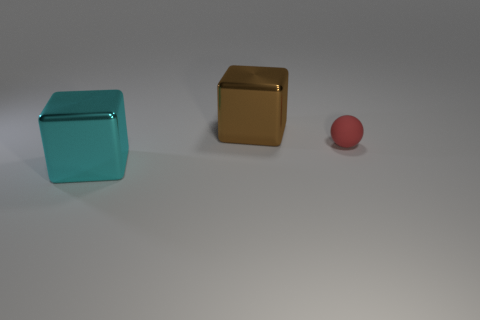Is there any other thing that has the same material as the sphere?
Your answer should be compact. No. Are there any other things that are the same size as the red rubber thing?
Offer a very short reply. No. There is a tiny rubber object; does it have the same shape as the thing left of the brown cube?
Your answer should be compact. No. What color is the object that is made of the same material as the cyan cube?
Provide a short and direct response. Brown. The tiny ball is what color?
Provide a succinct answer. Red. Do the brown cube and the big block that is in front of the tiny red rubber ball have the same material?
Your answer should be compact. Yes. What number of objects are both on the left side of the big brown cube and right of the big brown cube?
Your answer should be compact. 0. There is a brown thing that is the same size as the cyan block; what shape is it?
Provide a succinct answer. Cube. Are there any large cyan things right of the block that is in front of the brown object left of the red object?
Ensure brevity in your answer.  No. There is a matte ball; is it the same color as the large shiny block in front of the small object?
Give a very brief answer. No. 